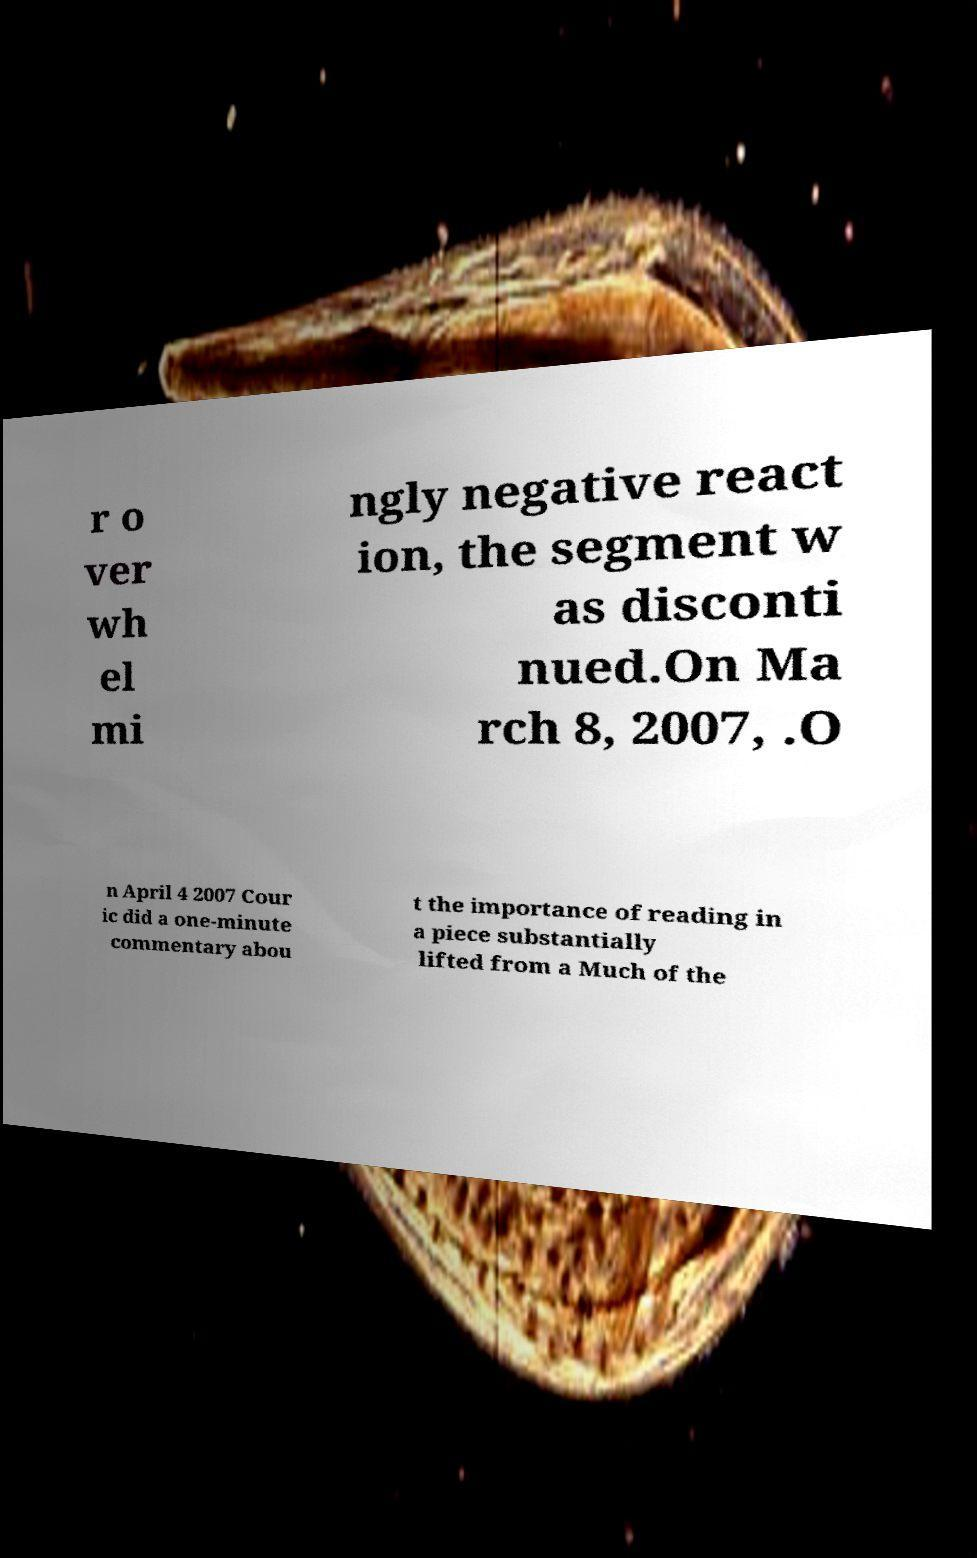Please identify and transcribe the text found in this image. r o ver wh el mi ngly negative react ion, the segment w as disconti nued.On Ma rch 8, 2007, .O n April 4 2007 Cour ic did a one-minute commentary abou t the importance of reading in a piece substantially lifted from a Much of the 